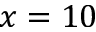Convert formula to latex. <formula><loc_0><loc_0><loc_500><loc_500>x = 1 0</formula> 